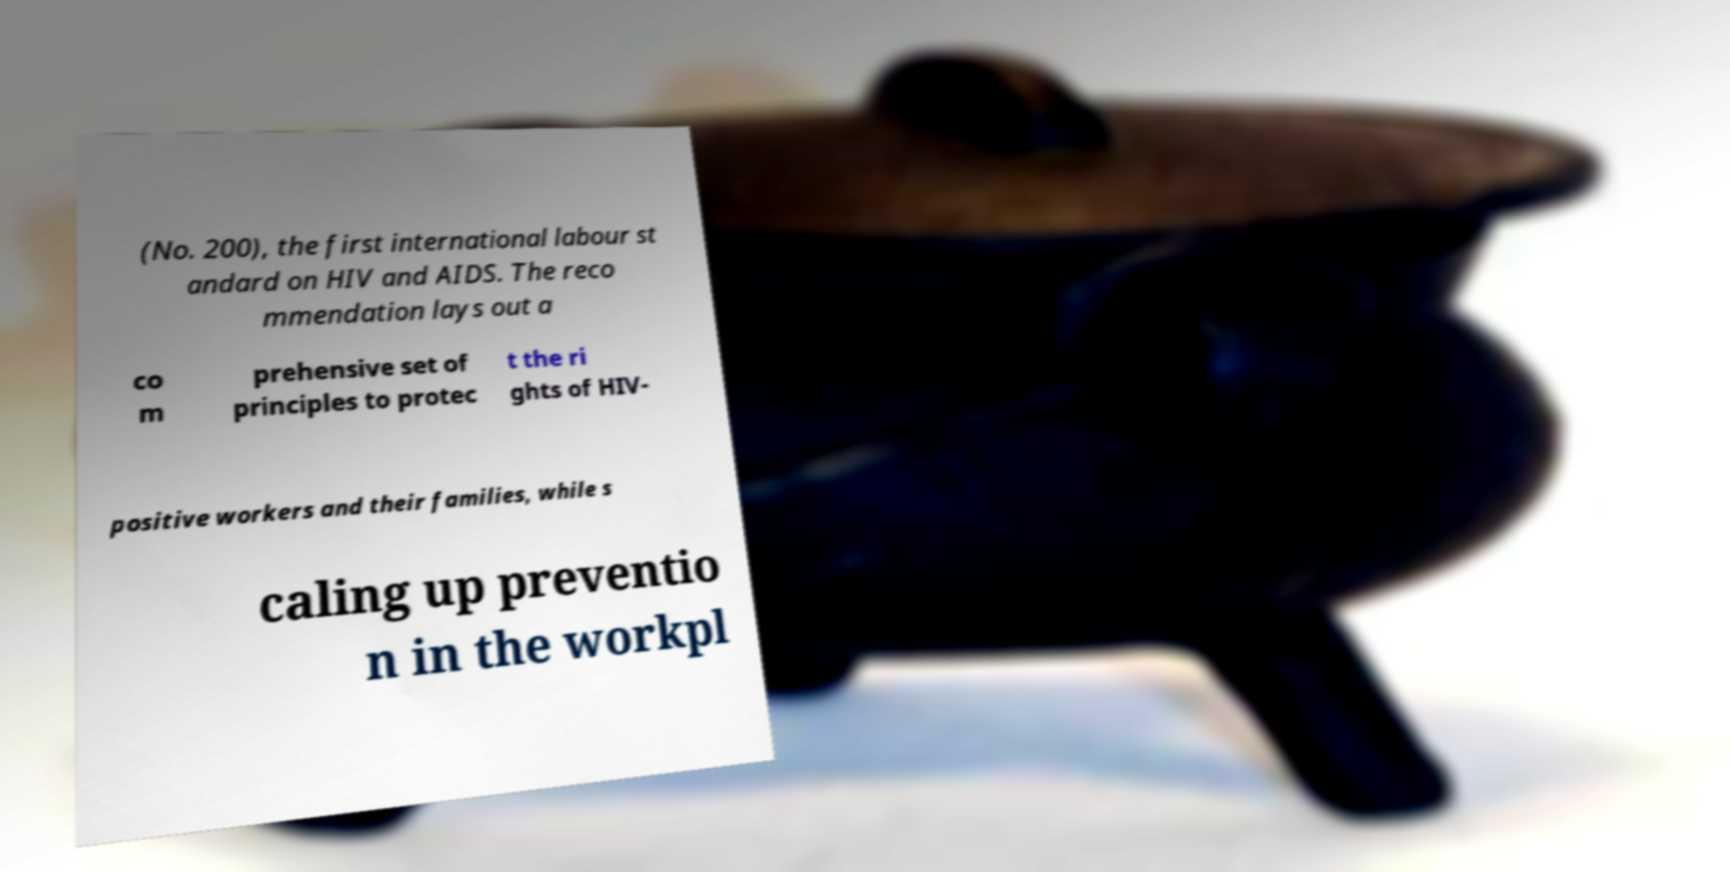Could you assist in decoding the text presented in this image and type it out clearly? (No. 200), the first international labour st andard on HIV and AIDS. The reco mmendation lays out a co m prehensive set of principles to protec t the ri ghts of HIV- positive workers and their families, while s caling up preventio n in the workpl 